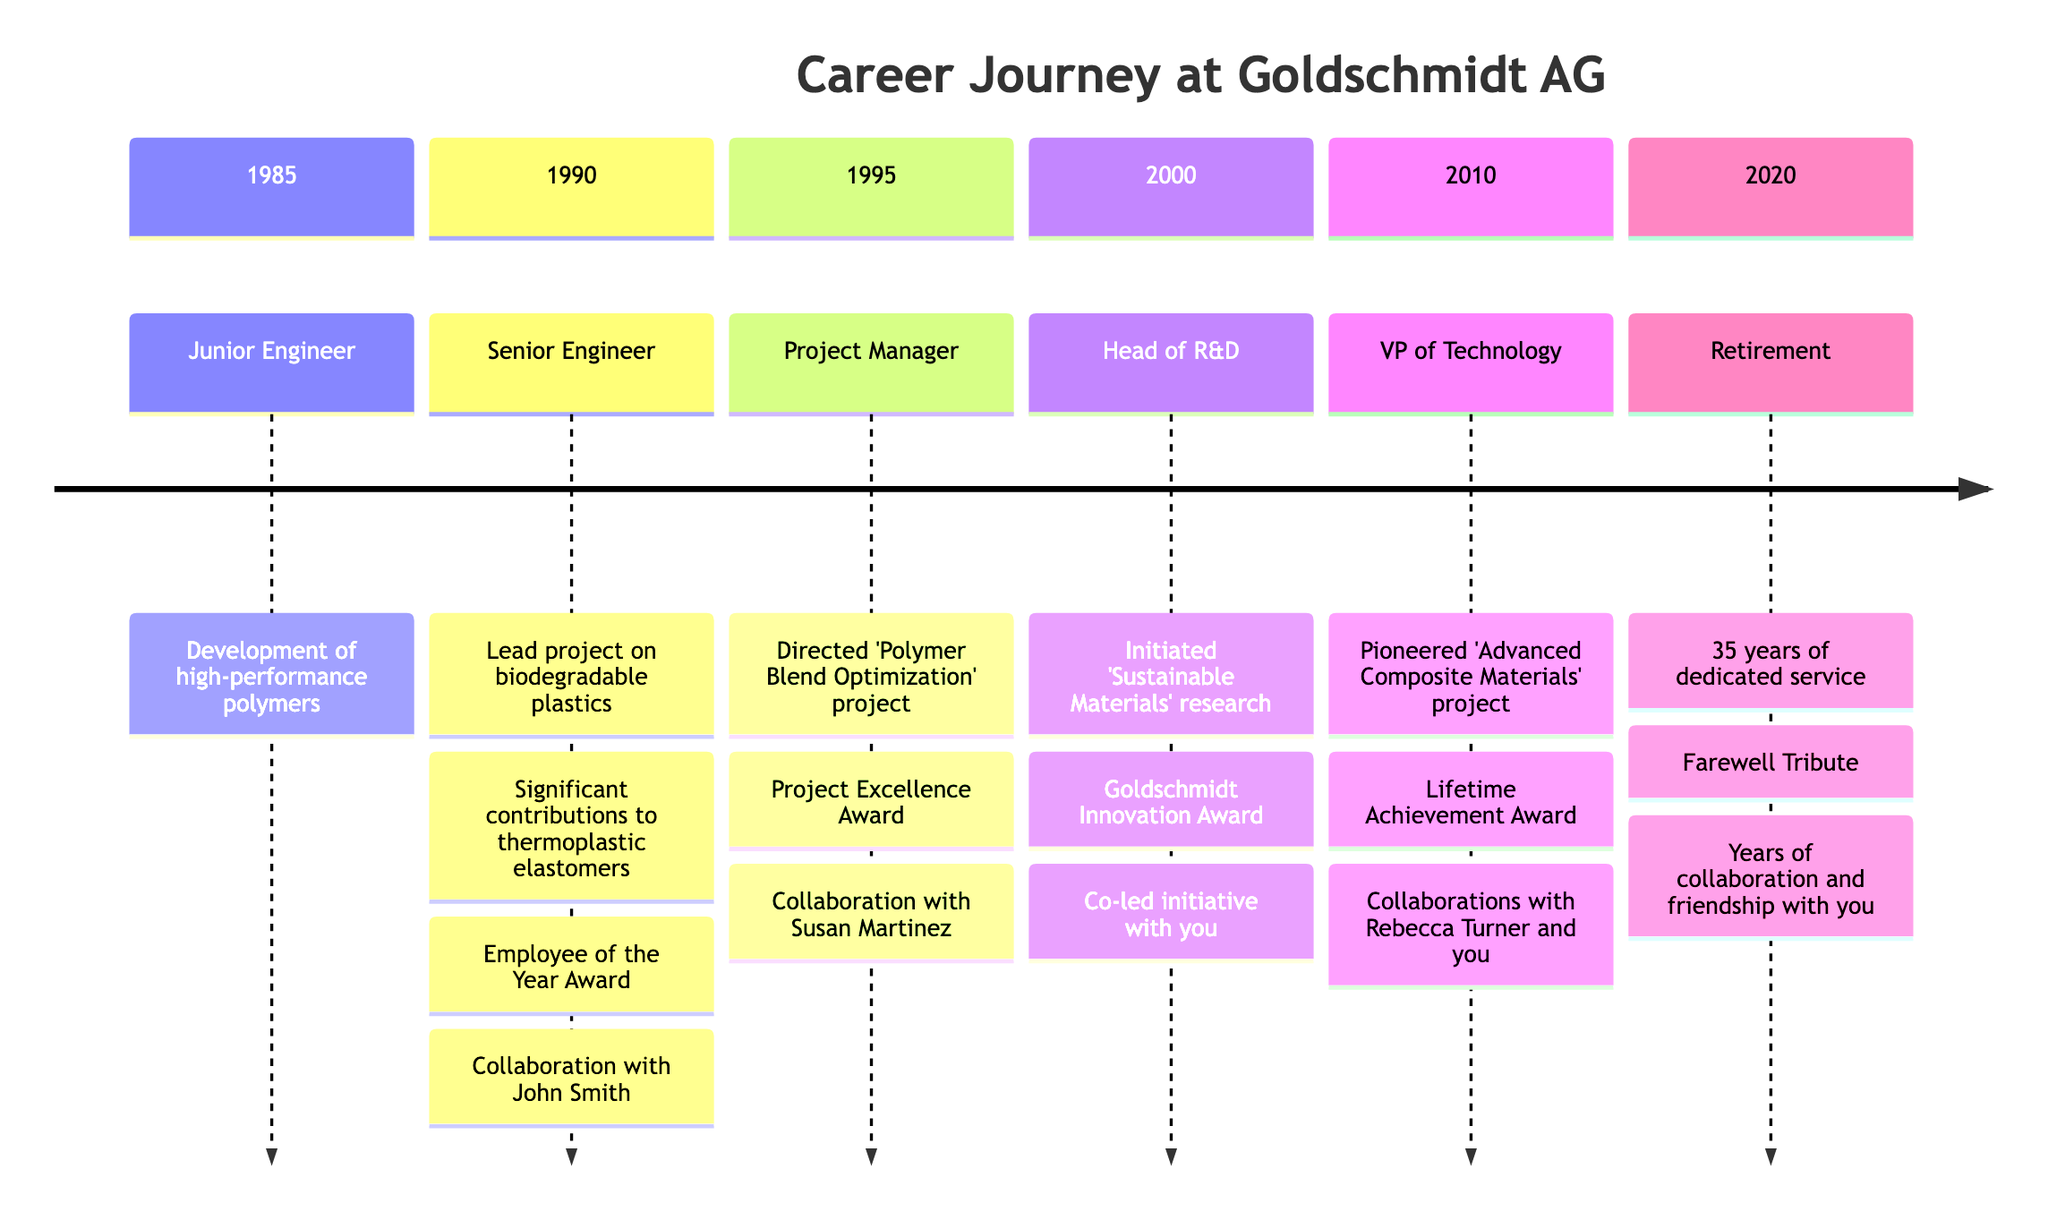What position did the retired employee hold in 1995? According to the timeline, in 1995, the retired employee was a Project Manager.
Answer: Project Manager How many awards did the employee receive in 2000? The diagram shows that in 2000, the employee received one award: the Goldschmidt Innovation Award.
Answer: 1 What was the major project in which the retired employee collaborated with you in 2000? The timeline indicates that you co-led the 'Sustainable Materials' research initiative in 2000.
Answer: Sustainable Materials Which major project was directed by the retired employee in 1995? Referencing the timeline, the major project directed by the retired employee in 1995 was the 'Polymer Blend Optimization' project.
Answer: Polymer Blend Optimization Which role did the retired employee hold when they received the Lifetime Achievement Award? The timeline states that the Lifetime Achievement Award was received while the retired employee was the Vice President of Technology in 2010.
Answer: Vice President of Technology What significant achievement occurred in 2010 related to project collaboration? In 2010, the retired employee collaborated with both Rebecca Turner and you on the 'Advanced Composite Materials' project, highlighting significant teamwork.
Answer: Advanced Composite Materials In what year did the retired employee initiate the 'Sustainable Materials' research initiative? According to the timeline, the 'Sustainable Materials' research initiative was initiated in the year 2000.
Answer: 2000 What is the year marking the retirement of the employee? The timeline lists the year 2020 as the year of retirement for the employee after 35 years of service.
Answer: 2020 How many major projects were led by the retired employee as Head of R&D? In the position of Head of R&D, the timeline shows that the retired employee initiated one major project: 'Sustainable Materials'.
Answer: 1 